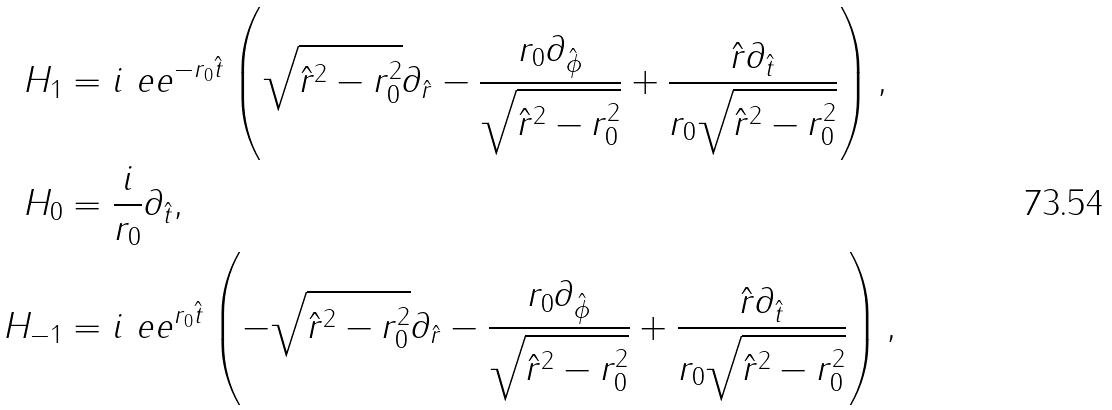<formula> <loc_0><loc_0><loc_500><loc_500>H _ { 1 } & = i \ e e ^ { - r _ { 0 } \hat { t } } \left ( \sqrt { \hat { r } ^ { 2 } - r _ { 0 } ^ { 2 } } \partial _ { \hat { r } } - \frac { r _ { 0 } \partial _ { \hat { \phi } } } { \sqrt { \hat { r } ^ { 2 } - r _ { 0 } ^ { 2 } } } + \frac { \hat { r } \partial _ { \hat { t } } } { r _ { 0 } \sqrt { \hat { r } ^ { 2 } - r _ { 0 } ^ { 2 } } } \right ) , \\ H _ { 0 } & = \frac { i } { r _ { 0 } } \partial _ { \hat { t } } , \\ H _ { - 1 } & = i \ e e ^ { r _ { 0 } \hat { t } } \left ( - \sqrt { \hat { r } ^ { 2 } - r _ { 0 } ^ { 2 } } \partial _ { \hat { r } } - \frac { r _ { 0 } \partial _ { \hat { \phi } } } { \sqrt { \hat { r } ^ { 2 } - r _ { 0 } ^ { 2 } } } + \frac { \hat { r } \partial _ { \hat { t } } } { r _ { 0 } \sqrt { \hat { r } ^ { 2 } - r _ { 0 } ^ { 2 } } } \right ) ,</formula> 